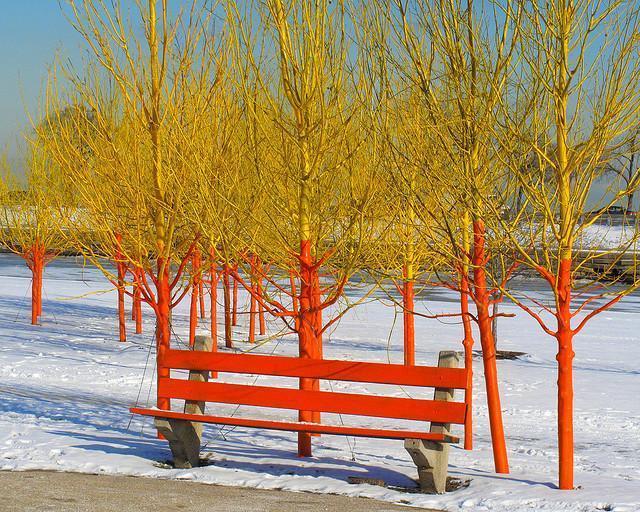How many clock faces?
Give a very brief answer. 0. 